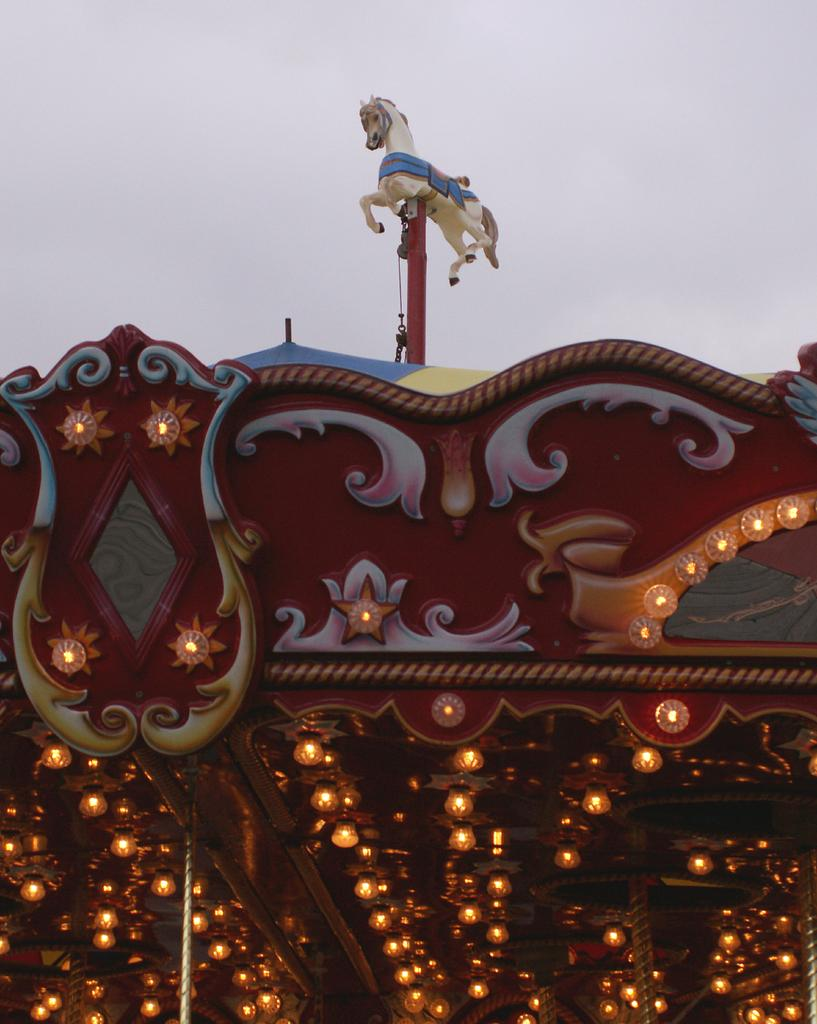What is the name of the amusement park ride in the image? The ride is called the "Go Round Ocean Carousel." What feature of the ride is mentioned in the image? The ride has lights. What decorative element is on top of the ride? There is a toy horse on the top of the ride. What can be seen in the background of the image? The sky is visible in the background of the image. What language is spoken by the rose in the image? There is no rose present in the image, and therefore no language can be spoken by it. 